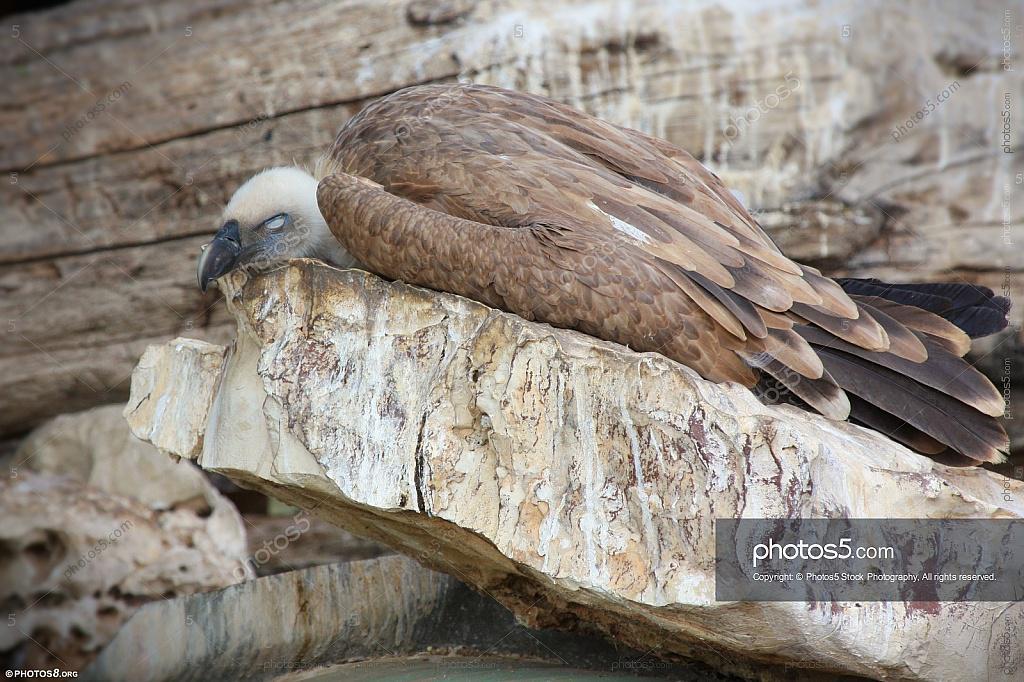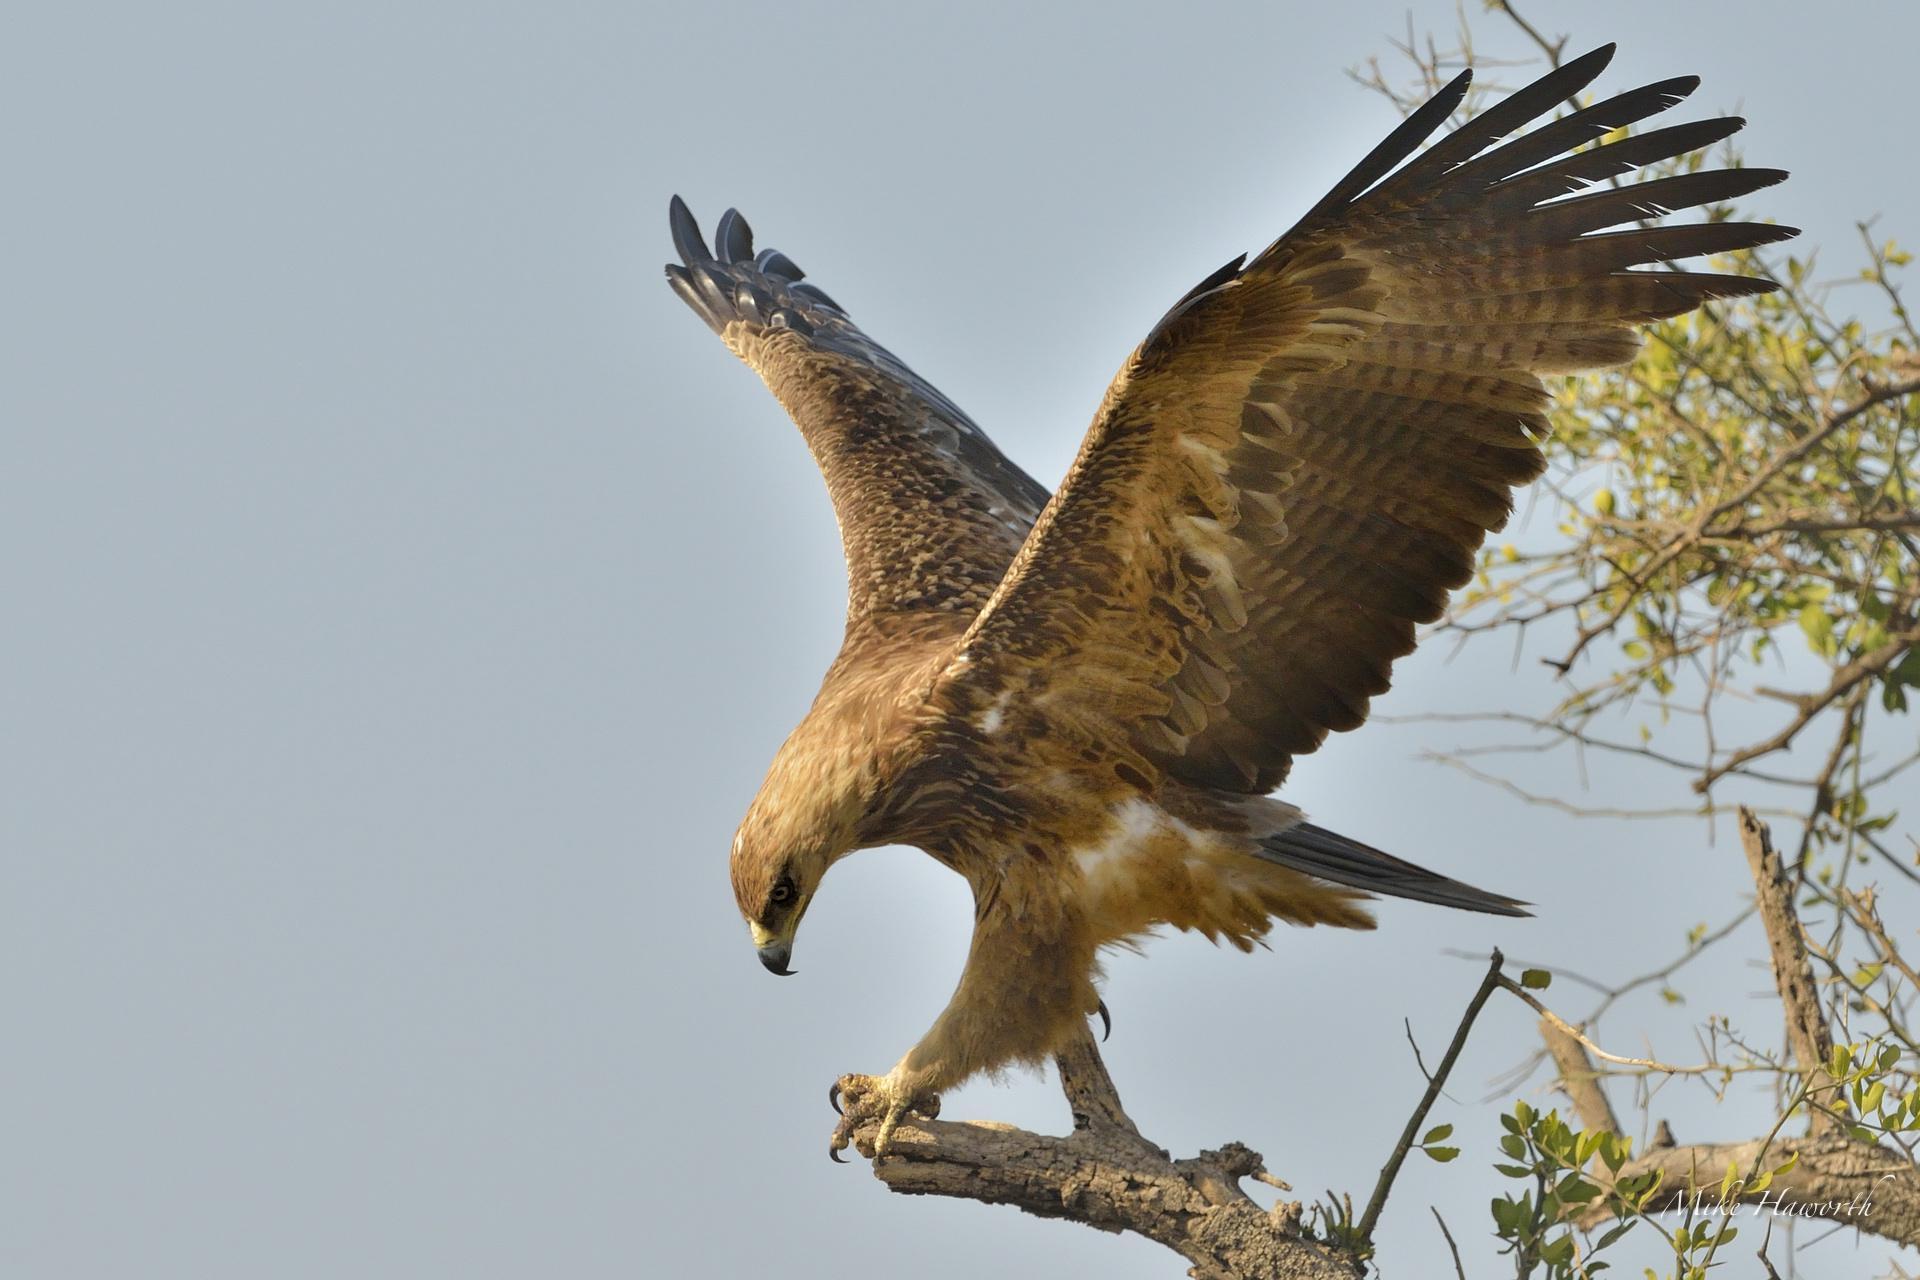The first image is the image on the left, the second image is the image on the right. Given the left and right images, does the statement "An image shows one vulture with its white fuzzy-feathered head on the left of the picture." hold true? Answer yes or no. Yes. 